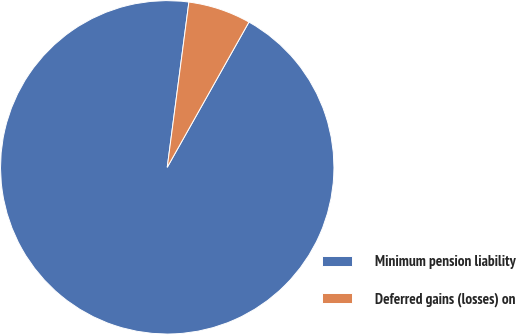Convert chart to OTSL. <chart><loc_0><loc_0><loc_500><loc_500><pie_chart><fcel>Minimum pension liability<fcel>Deferred gains (losses) on<nl><fcel>93.92%<fcel>6.08%<nl></chart> 